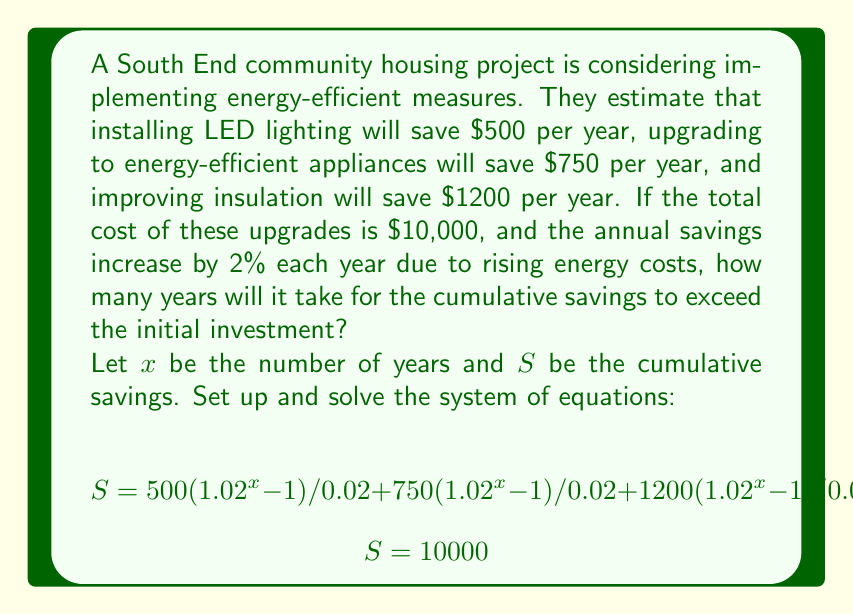Give your solution to this math problem. To solve this problem, we'll follow these steps:

1) First, let's simplify the equation for cumulative savings:
   $$S = (500 + 750 + 1200)(1.02^x - 1)/0.02 = 122500(1.02^x - 1)$$

2) Now we have the system:
   $$122500(1.02^x - 1) = 10000$$

3) Solve for $x$:
   $$1.02^x - 1 = 10000/122500 = 0.0816$$
   $$1.02^x = 1.0816$$
   $$x \log(1.02) = \log(1.0816)$$
   $$x = \log(1.0816) / \log(1.02) = 3.99$$

4) Since we can't have a fractional year, we round up to the nearest whole year.

This calculation shows that it will take 4 years for the cumulative savings to exceed the initial investment.

5) To verify:
   Year 1: $2450 * 1.00 = 2450$
   Year 2: $2450 * 1.02 = 2499$
   Year 3: $2450 * 1.02^2 = 2549$
   Year 4: $2450 * 1.02^3 = 2600$
   Total after 4 years: $10098 > 10000$
Answer: It will take 4 years for the cumulative savings to exceed the initial investment of $10,000. 